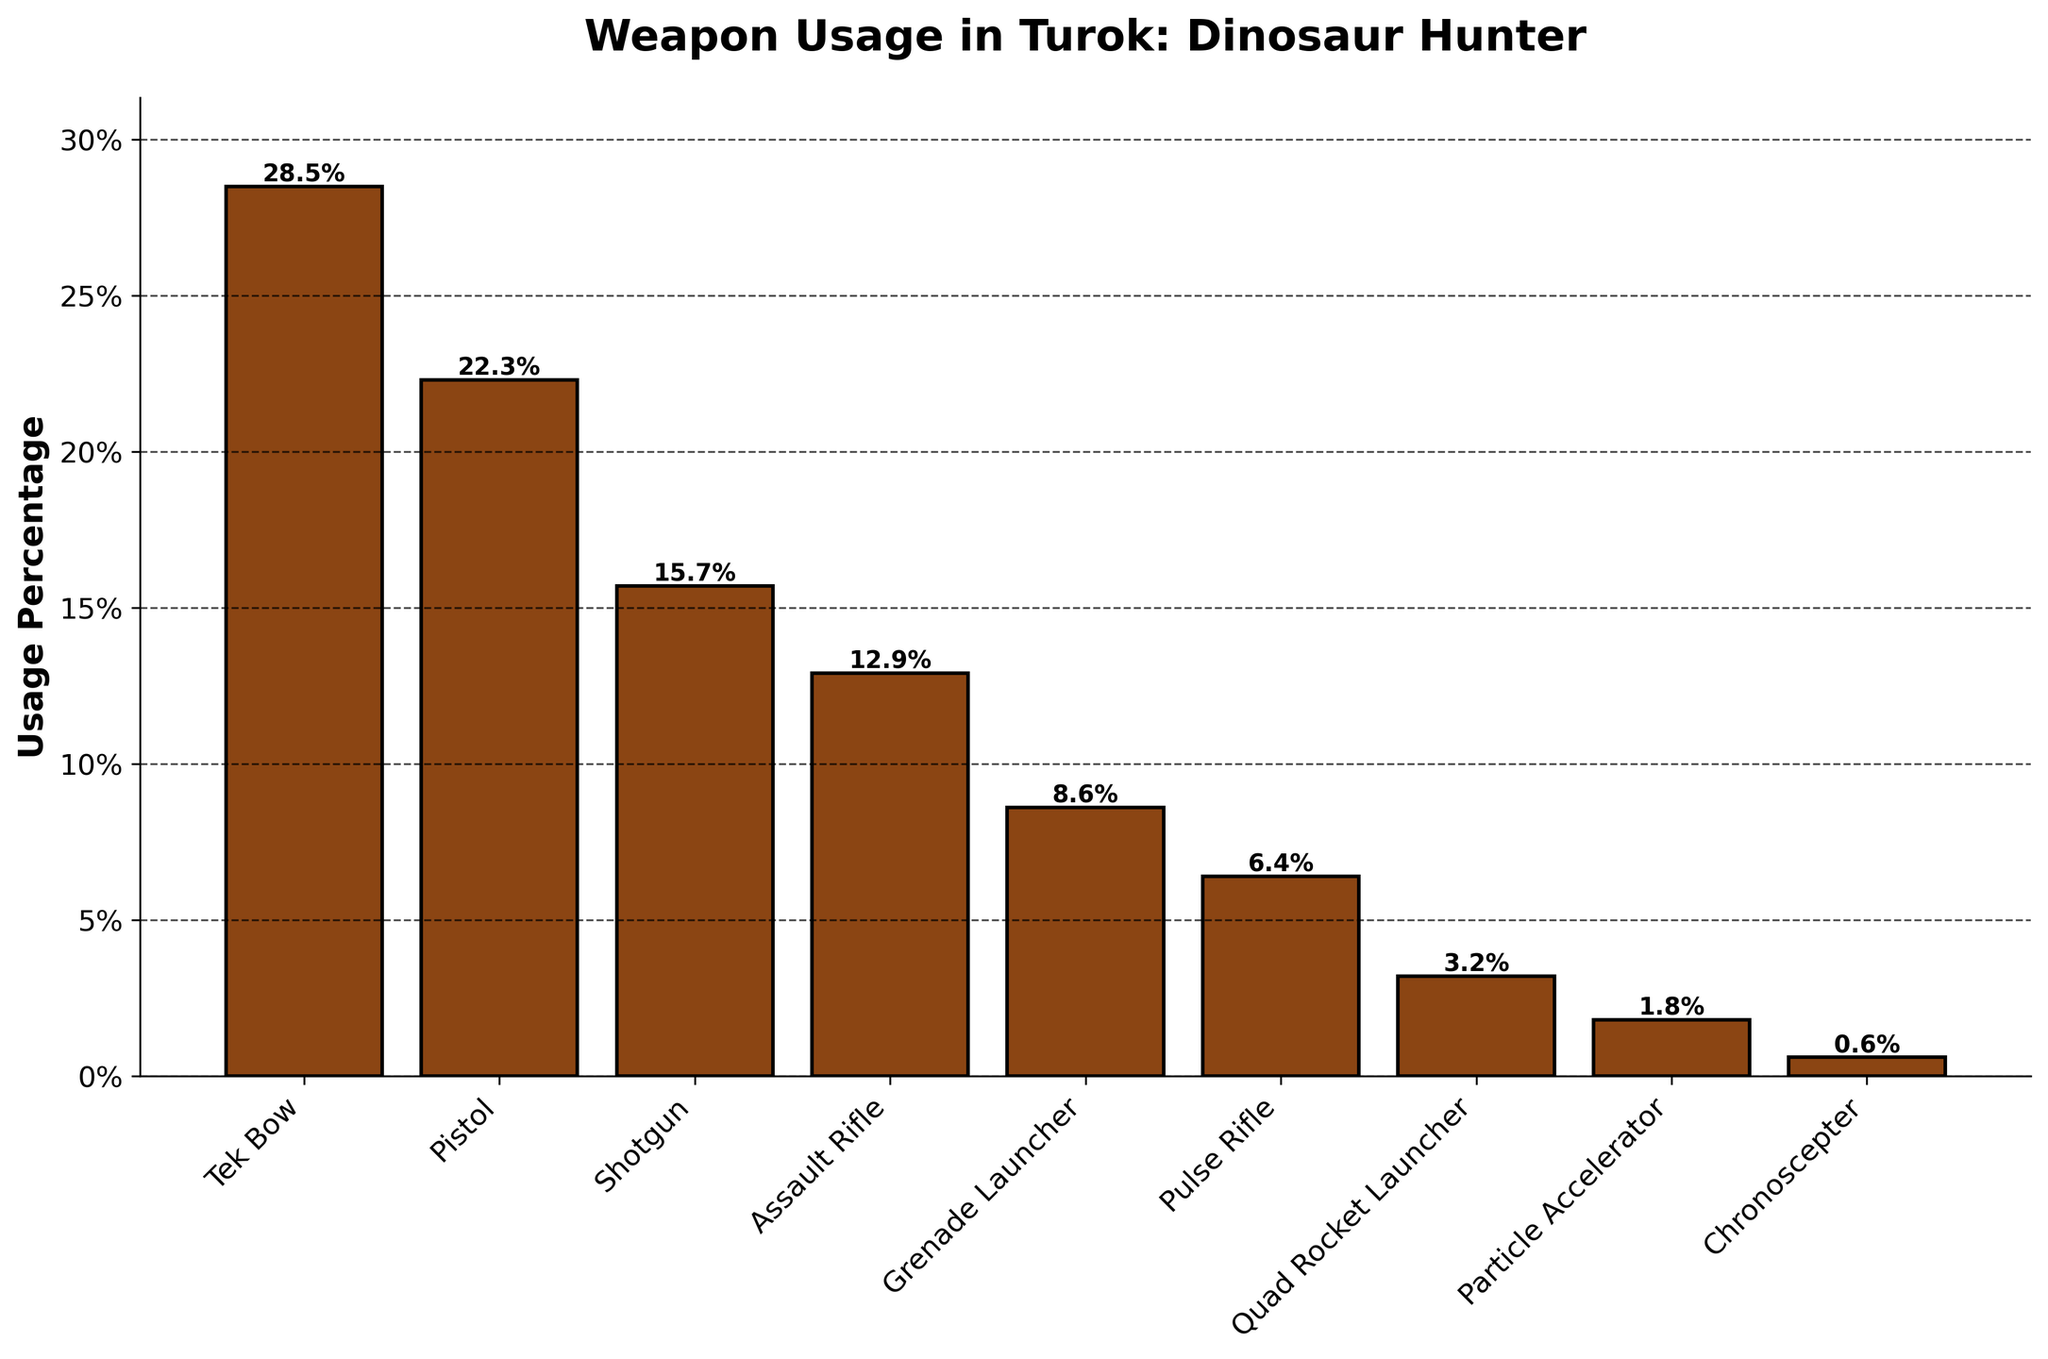What's the most used weapon in Turok: Dinosaur Hunter? The weapon with the highest usage percentage (the tallest bar). In the figure, Tek Bow has the highest usage percentage at 28.5%.
Answer: Tek Bow Which weapon is used the least in Turok: Dinosaur Hunter? The weapon with the smallest usage percentage (the shortest bar). In the figure, Chronoscepter has the lowest usage percentage at 0.6%.
Answer: Chronoscepter How does the usage of the Pistol compare to the Assault Rifle? Look at the heights of the bars for the Pistol and Assault Rifle and their respective percentage labels. Pistol is used 22.3%, while Assault Rifle is used 12.9%.
Answer: Pistol is used more Which weapon group has a combined usage greater: Shotgun and Assault Rifle or Grenade Launcher and Pulse Rifle? Sum the usage percentages and compare them. Shotgun (15.7%) + Assault Rifle (12.9%) = 28.6%. Grenade Launcher (8.6%) + Pulse Rifle (6.4%) = 15.0%.
Answer: Shotgun and Assault Rifle What percentage of total usage is accounted for by the top three most used weapons? Sum the usage percentages of Tek Bow, Pistol, and Shotgun. Tek Bow (28.5%) + Pistol (22.3%) + Shotgun (15.7%) = 66.5%.
Answer: 66.5% Among the weapons with less than 10% usage, which one has the highest usage? Identify the weapons with usage percentages below 10% and compare them. Grenade Launcher (8.6%) is the highest among those below 10%.
Answer: Grenade Launcher What's the difference in usage percentage between the Quad Rocket Launcher and the Pulse Rifle? Subtract the usage percentage of the Quad Rocket Launcher from that of the Pulse Rifle. Pulse Rifle (6.4%) - Quad Rocket Launcher (3.2%) = 3.2%.
Answer: 3.2% Which weapons have a usage percentage within 5% of each other? Compare the usage percentages and find pairs within a 5% difference. Tek Bow (28.5%) and Pistol (22.3%)—difference 6.2%, Pulse Rifle (6.4%) and Quad Rocket Launcher (3.2%)—difference 3.2%.
Answer: Pulse Rifle and Quad Rocket Launcher What is the average usage percentage across all weapons? Sum all the usage percentages and divide by the number of weapons. Sum = 28.5 + 22.3 + 15.7 + 12.9 + 8.6 + 6.4 + 3.2 + 1.8 + 0.6 = 100.
Answer: 11.1% What percentage of total usage do the least three used weapons account for? Sum the usage percentages of the Particle Accelerator, Quad Rocket Launcher, and Chronoscepter. 1.8% + 3.2% + 0.6% = 5.6%.
Answer: 5.6% 